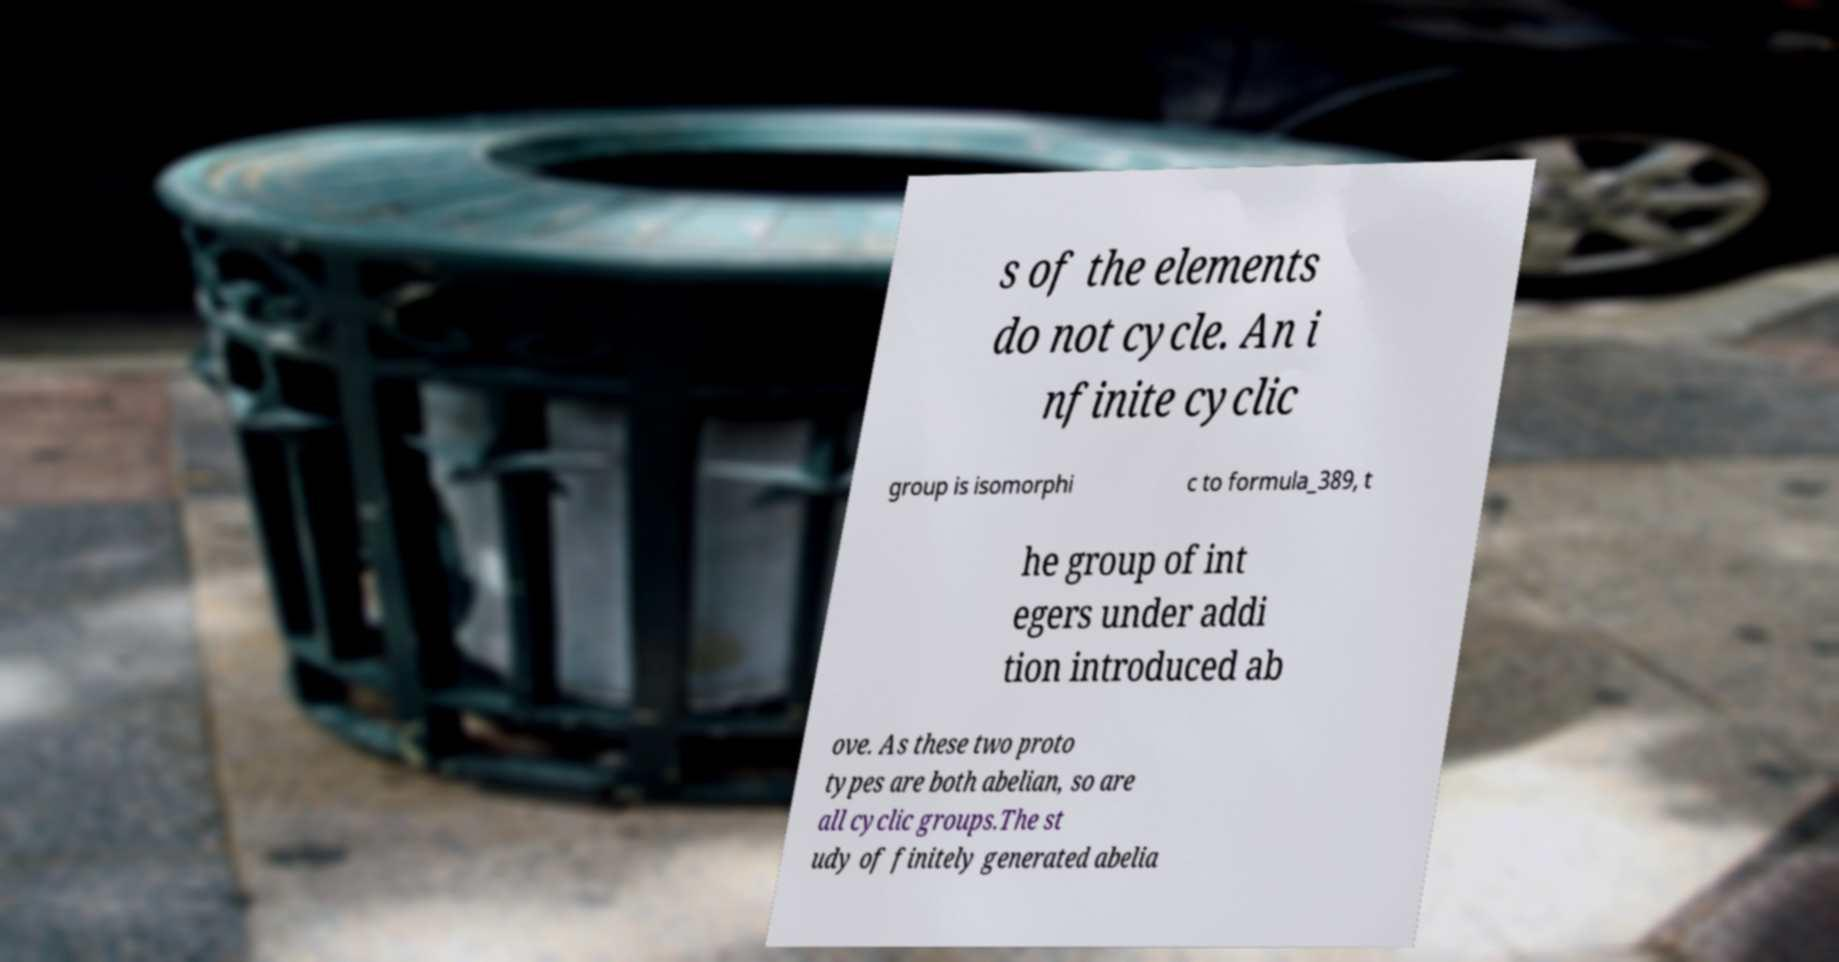Can you accurately transcribe the text from the provided image for me? s of the elements do not cycle. An i nfinite cyclic group is isomorphi c to formula_389, t he group of int egers under addi tion introduced ab ove. As these two proto types are both abelian, so are all cyclic groups.The st udy of finitely generated abelia 